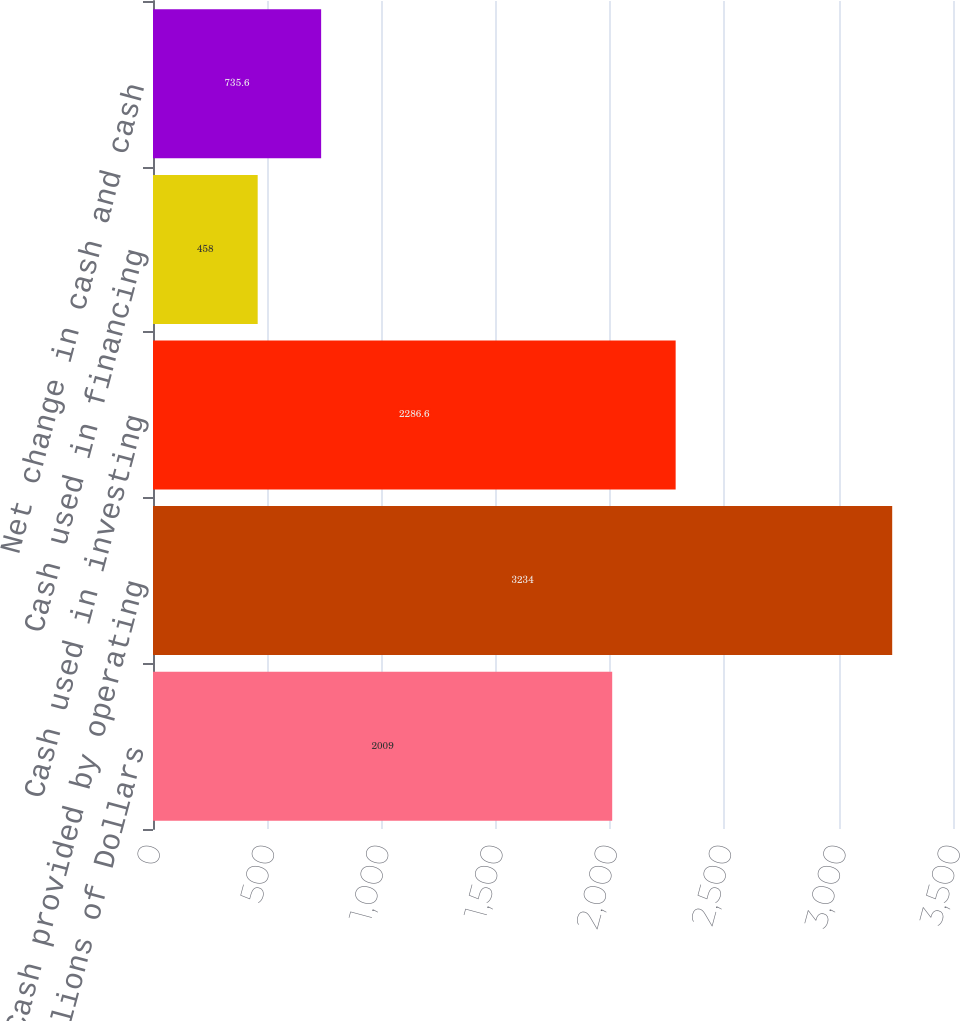Convert chart to OTSL. <chart><loc_0><loc_0><loc_500><loc_500><bar_chart><fcel>Cash Flows Millions of Dollars<fcel>Cash provided by operating<fcel>Cash used in investing<fcel>Cash used in financing<fcel>Net change in cash and cash<nl><fcel>2009<fcel>3234<fcel>2286.6<fcel>458<fcel>735.6<nl></chart> 